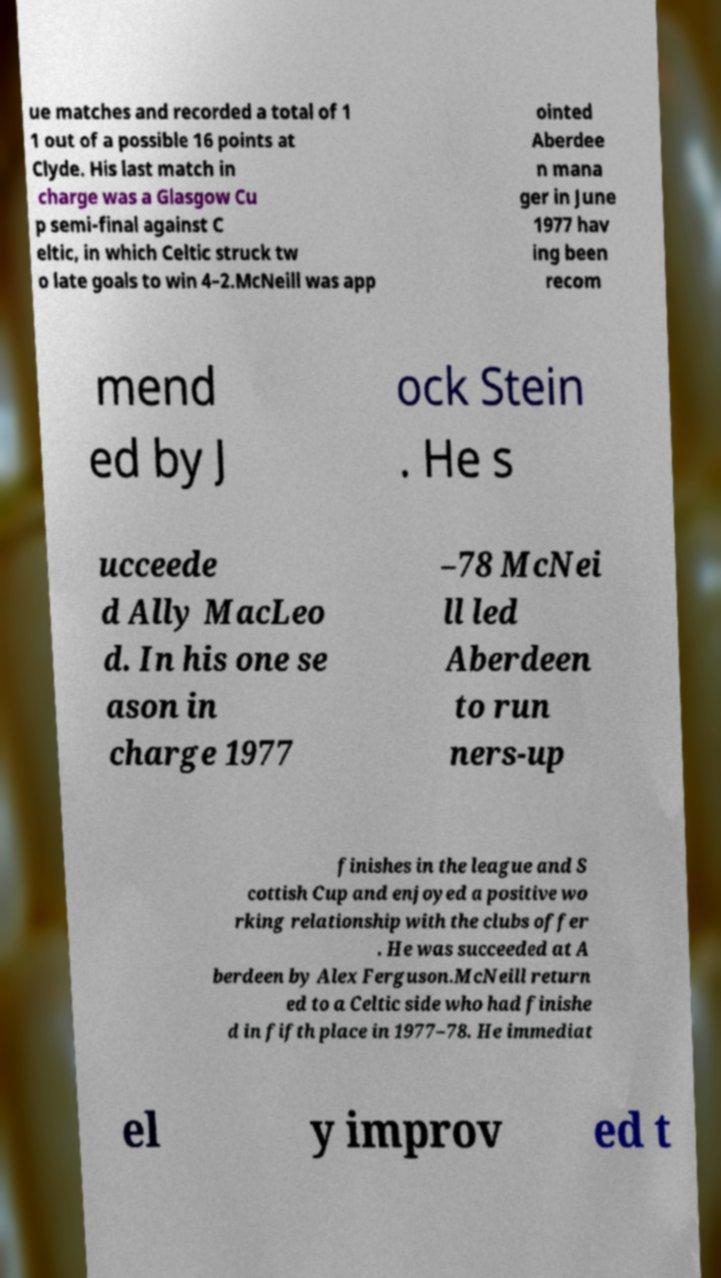I need the written content from this picture converted into text. Can you do that? ue matches and recorded a total of 1 1 out of a possible 16 points at Clyde. His last match in charge was a Glasgow Cu p semi-final against C eltic, in which Celtic struck tw o late goals to win 4–2.McNeill was app ointed Aberdee n mana ger in June 1977 hav ing been recom mend ed by J ock Stein . He s ucceede d Ally MacLeo d. In his one se ason in charge 1977 –78 McNei ll led Aberdeen to run ners-up finishes in the league and S cottish Cup and enjoyed a positive wo rking relationship with the clubs offer . He was succeeded at A berdeen by Alex Ferguson.McNeill return ed to a Celtic side who had finishe d in fifth place in 1977–78. He immediat el y improv ed t 